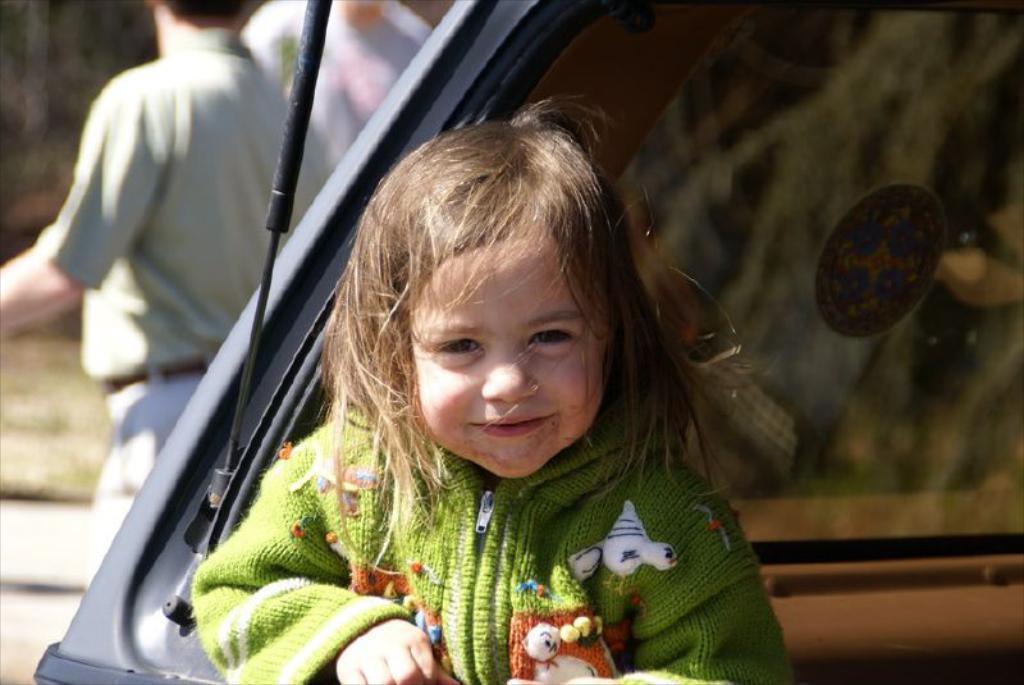In one or two sentences, can you explain what this image depicts? In this picture we can see a kid is smiling in the front, on the right side there is a glass, in the background we can see another person, there is a blurry background. 